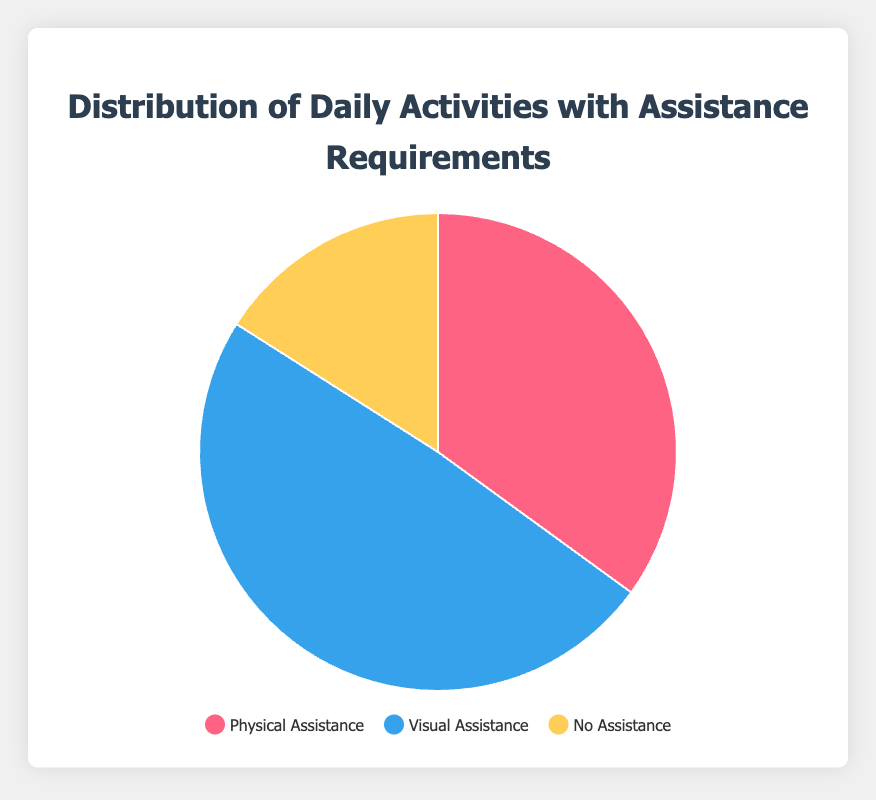What percentage of activities require visual assistance? The pie chart shows the average percentages for each type of assistance. From the chart data, visual assistance is represented by the blue section, which is 49%.
Answer: 49% Which type of assistance is required the most according to the pie chart? The pie chart shows three types of assistance with their respective percentages. Visual assistance has the highest percentage at 49% compared to physical assistance at 35% and no assistance at 16%.
Answer: Visual assistance What is the difference between the percentage of physical assistance and no assistance required? According to the chart, physical assistance accounts for 35% and no assistance accounts for 16%. The difference is 35% - 16% = 19%.
Answer: 19% Which color in the pie chart represents no assistance? The pie chart uses three colors to represent the different types of assistance. The yellow segment corresponds to no assistance.
Answer: Yellow If you sum the percentages of physical and visual assistance, what is the total? The chart shows that physical assistance is 35% and visual assistance is 49%. Summing these two percentages gives 35% + 49% = 84%.
Answer: 84% Is the percentage of no assistance greater than, less than, or equal to 20%? According to the chart, no assistance is represented by the yellow segment, which is 16%. This is less than 20%.
Answer: Less than 20% How much more percentage is visual assistance than physical assistance? Visual assistance is 49% and physical assistance is 35%. The difference is 49% - 35% = 14%.
Answer: 14% Which type of assistance has the smallest representation in the pie chart? Looking at the chart, no assistance is the smallest segment at 16%, compared to physical at 35% and visual at 49%.
Answer: No assistance 